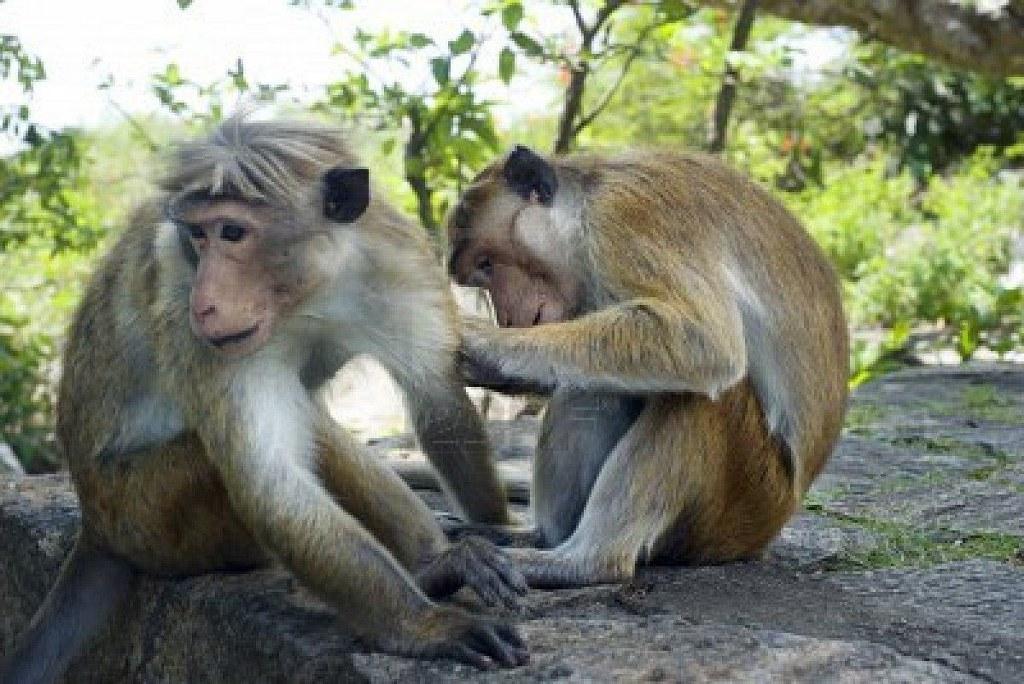How would you summarize this image in a sentence or two? In the image we can see two monkeys sitting. Here we can see the rock, trees and the background is slightly blurred. 